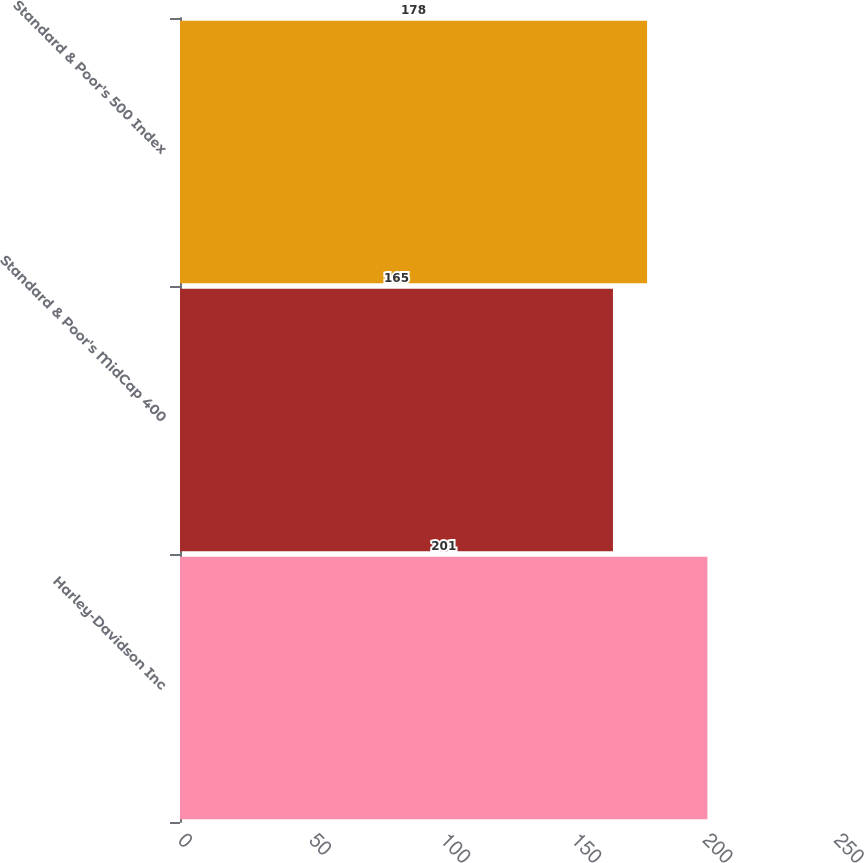Convert chart. <chart><loc_0><loc_0><loc_500><loc_500><bar_chart><fcel>Harley-Davidson Inc<fcel>Standard & Poor's MidCap 400<fcel>Standard & Poor's 500 Index<nl><fcel>201<fcel>165<fcel>178<nl></chart> 